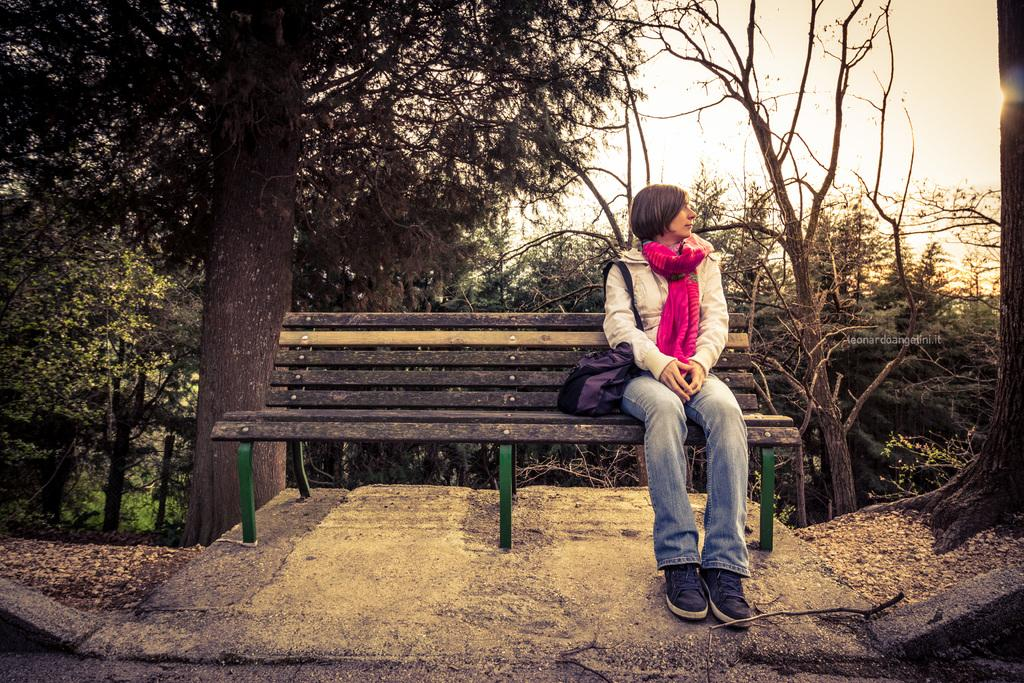What type of seating is present in the image? There is a bench in the image. Who is sitting on the bench? A person is sitting on the bench. What is the person doing with a bag in the image? The person is hanging a bag on her shoulder. What accessory is the person wearing in the image? The person is wearing a scarf. What can be seen in the background of the image? There are trees visible in the background of the image. What type of face patch is visible on the person's face in the image? There is no face patch visible on the person's face in the image. What impulse might the person be experiencing while sitting on the bench? It is impossible to determine the person's impulses from the image alone. 